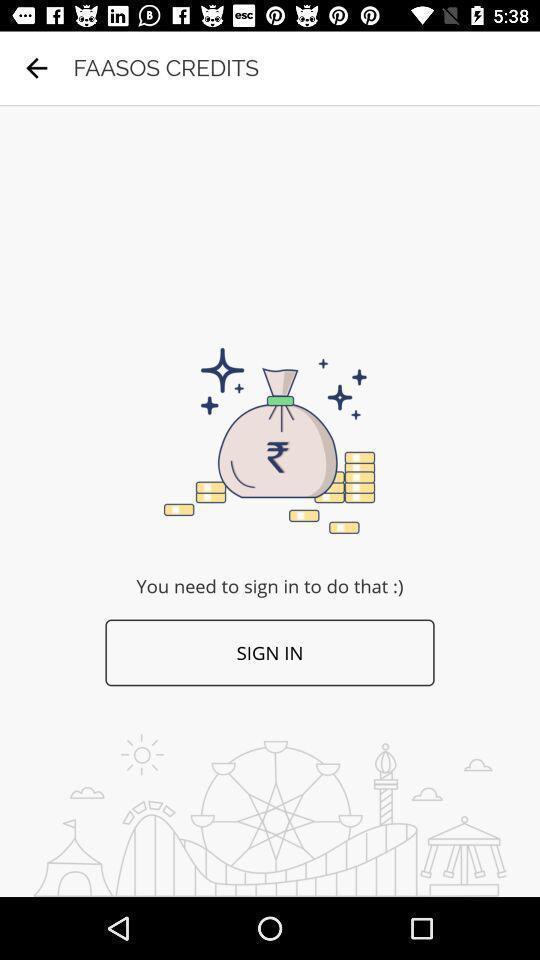Tell me what you see in this picture. Sign-in page is displaying. 